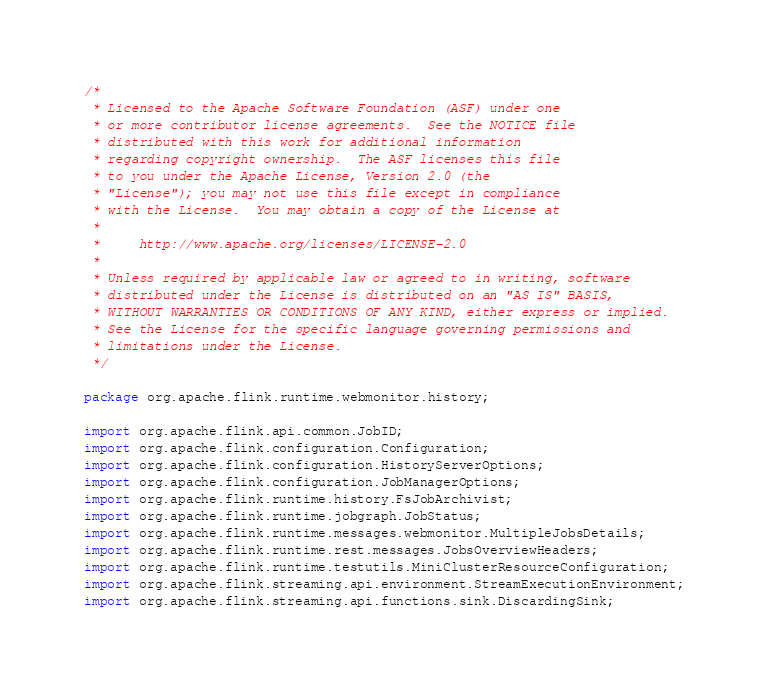Convert code to text. <code><loc_0><loc_0><loc_500><loc_500><_Java_>/*
 * Licensed to the Apache Software Foundation (ASF) under one
 * or more contributor license agreements.  See the NOTICE file
 * distributed with this work for additional information
 * regarding copyright ownership.  The ASF licenses this file
 * to you under the Apache License, Version 2.0 (the
 * "License"); you may not use this file except in compliance
 * with the License.  You may obtain a copy of the License at
 *
 *     http://www.apache.org/licenses/LICENSE-2.0
 *
 * Unless required by applicable law or agreed to in writing, software
 * distributed under the License is distributed on an "AS IS" BASIS,
 * WITHOUT WARRANTIES OR CONDITIONS OF ANY KIND, either express or implied.
 * See the License for the specific language governing permissions and
 * limitations under the License.
 */

package org.apache.flink.runtime.webmonitor.history;

import org.apache.flink.api.common.JobID;
import org.apache.flink.configuration.Configuration;
import org.apache.flink.configuration.HistoryServerOptions;
import org.apache.flink.configuration.JobManagerOptions;
import org.apache.flink.runtime.history.FsJobArchivist;
import org.apache.flink.runtime.jobgraph.JobStatus;
import org.apache.flink.runtime.messages.webmonitor.MultipleJobsDetails;
import org.apache.flink.runtime.rest.messages.JobsOverviewHeaders;
import org.apache.flink.runtime.testutils.MiniClusterResourceConfiguration;
import org.apache.flink.streaming.api.environment.StreamExecutionEnvironment;
import org.apache.flink.streaming.api.functions.sink.DiscardingSink;</code> 